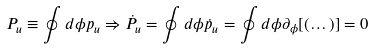<formula> <loc_0><loc_0><loc_500><loc_500>P _ { u } \equiv \oint d \phi p _ { u } \Rightarrow \dot { P } _ { u } = \oint d \phi \dot { p } _ { u } = \oint d \phi \partial _ { \phi } [ ( \dots ) ] = 0</formula> 